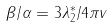Convert formula to latex. <formula><loc_0><loc_0><loc_500><loc_500>\beta / \alpha = 3 \lambda _ { 2 } ^ { * } / 4 \pi v</formula> 